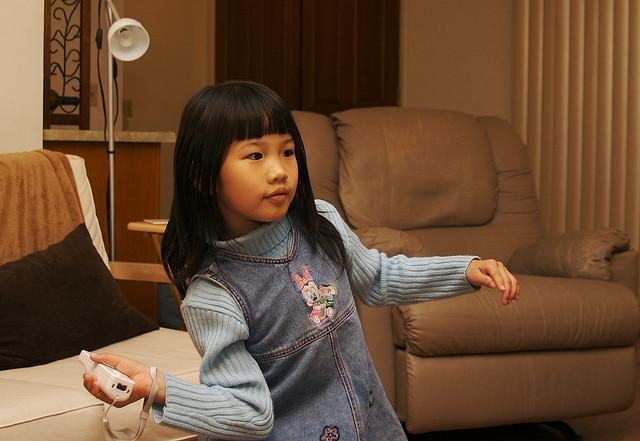Who created the character on the girls dress?
Choose the right answer and clarify with the format: 'Answer: answer
Rationale: rationale.'
Options: Walt disney, dreamworks, pixar, warner brothers. Answer: walt disney.
Rationale: The character on the girl's dress is mickey mouse who was created by walt disney. 